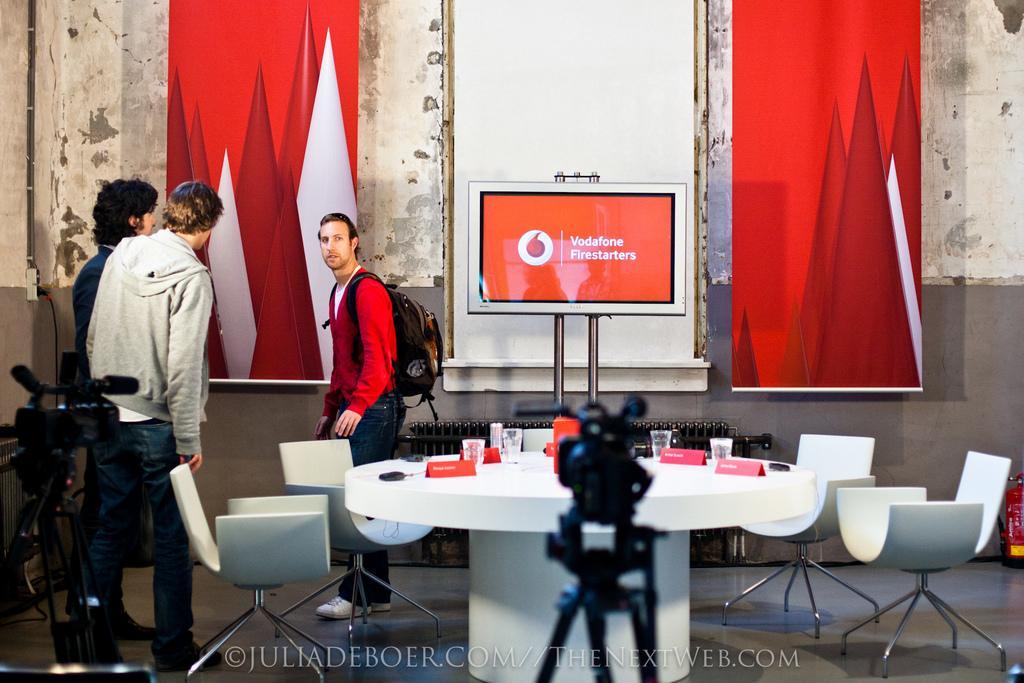Could you give a brief overview of what you see in this image? This is a picture taken in a room, there are a three are people standing on the floor. In front of the people there is a white color table on the table there is a name board, glasses. On the floor there are the two cameras background of this people is a wall and a hoardings. 